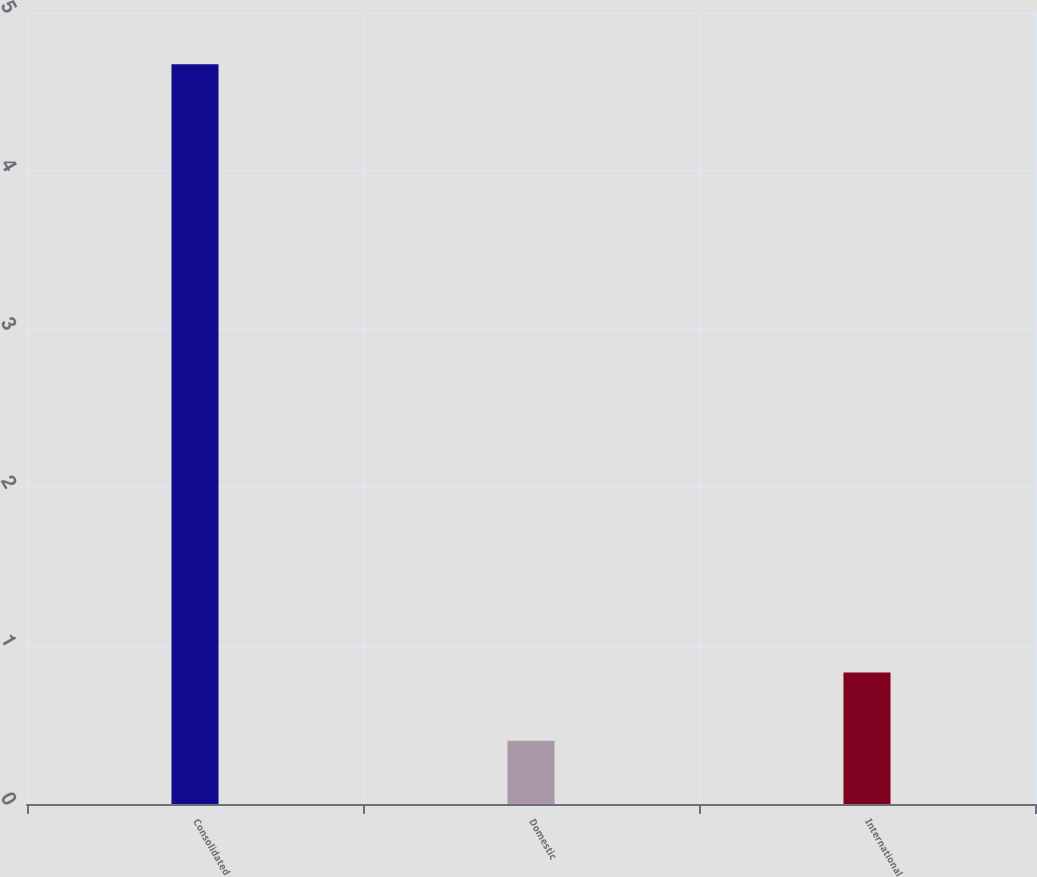<chart> <loc_0><loc_0><loc_500><loc_500><bar_chart><fcel>Consolidated<fcel>Domestic<fcel>International<nl><fcel>4.67<fcel>0.4<fcel>0.83<nl></chart> 